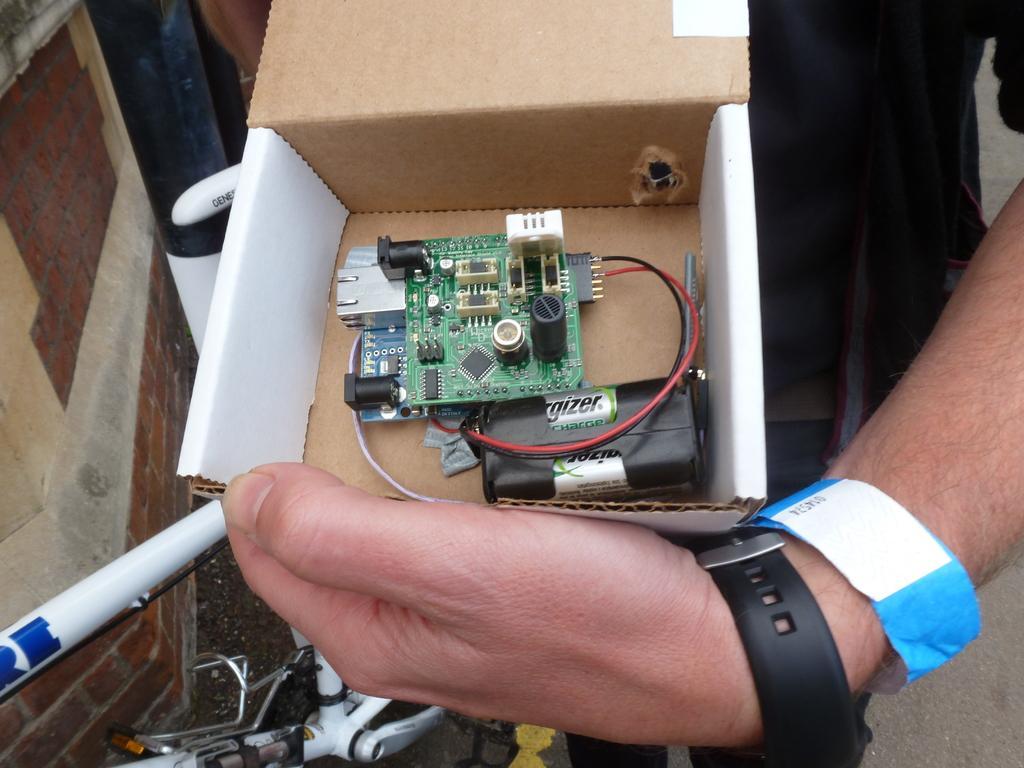In one or two sentences, can you explain what this image depicts? In this image I can see a person is holding a cartoon box in hand in which a circuit board and batteries are there. In the left I can see a wall and bicycle. This image is taken during a day. 